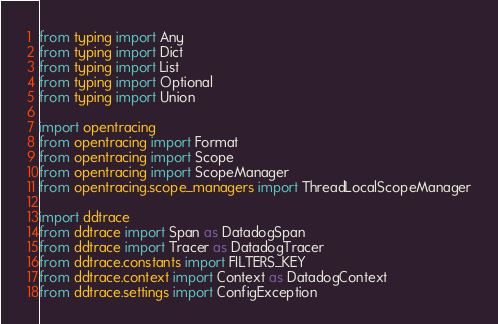Convert code to text. <code><loc_0><loc_0><loc_500><loc_500><_Python_>from typing import Any
from typing import Dict
from typing import List
from typing import Optional
from typing import Union

import opentracing
from opentracing import Format
from opentracing import Scope
from opentracing import ScopeManager
from opentracing.scope_managers import ThreadLocalScopeManager

import ddtrace
from ddtrace import Span as DatadogSpan
from ddtrace import Tracer as DatadogTracer
from ddtrace.constants import FILTERS_KEY
from ddtrace.context import Context as DatadogContext
from ddtrace.settings import ConfigException</code> 